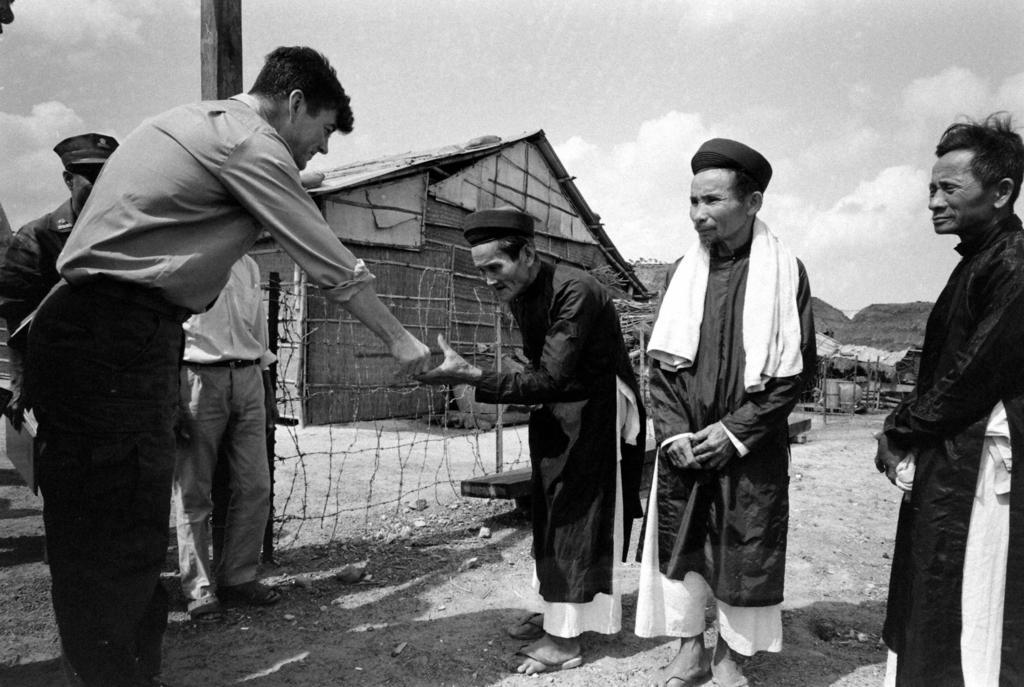Describe this image in one or two sentences. Here we can see few persons. There is a fence. Here we can see huts and a pole. In the background there is sky with clouds. 